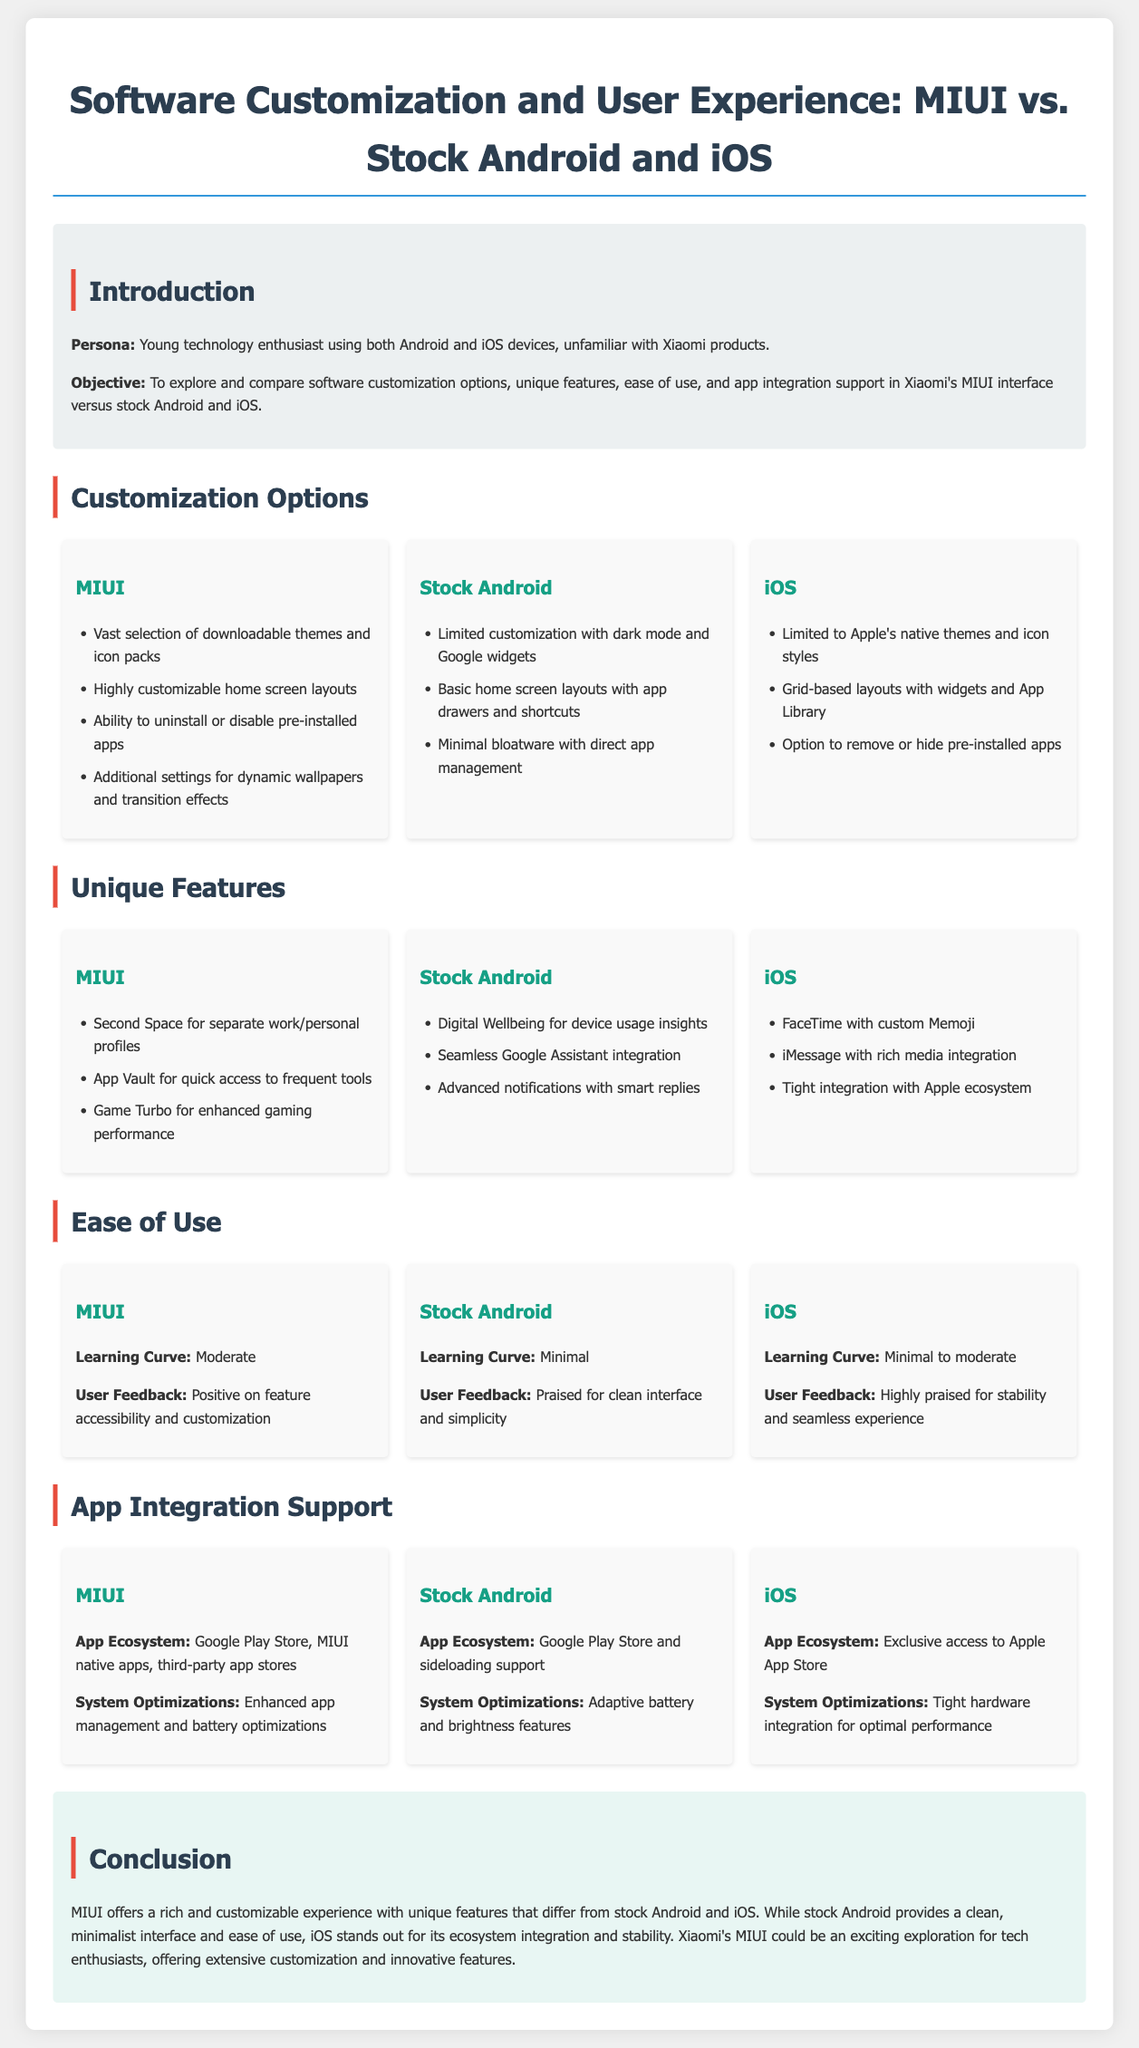What are the customization options available in MIUI? The customization options in MIUI include a vast selection of downloadable themes and icon packs, highly customizable home screen layouts, the ability to uninstall or disable pre-installed apps, and additional settings for dynamic wallpapers and transition effects.
Answer: Downloadable themes and icon packs, customizable home screen layouts, uninstall pre-installed apps, dynamic wallpapers What unique feature does MIUI offer for managing profiles? MIUI has a unique feature called Second Space, which allows users to create separate work and personal profiles.
Answer: Second Space What is the learning curve for Stock Android? The learning curve for Stock Android is indicated as minimal, making it easy for users to navigate.
Answer: Minimal How does MIUI's app ecosystem compare to Stock Android? MIUI's app ecosystem includes the Google Play Store, MIUI native apps, and third-party app stores, whereas Stock Android features the Google Play Store and sideloading support.
Answer: Google Play Store, MIUI native apps, third-party app stores Which interface has the highest praise for stability according to user feedback? User feedback highlights iOS for its highly praised stability and seamless experience compared to other systems.
Answer: iOS 